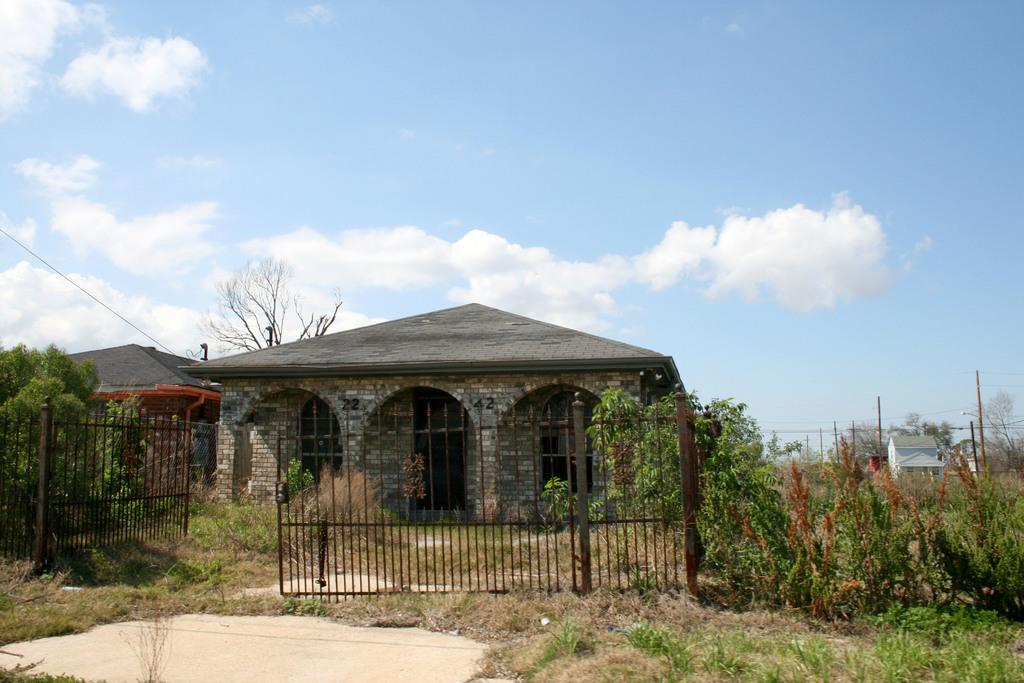What type of vegetation can be seen in the image? There is grass and plants in the image. What type of structure is present in the image? There is a gate in the image. What other objects can be seen in the image? There are poles and houses in the image. What type of natural elements are visible in the image? There are trees and the sky in the image. What can be seen in the sky in the image? There are clouds in the sky. What type of marble is used to decorate the rail in the image? There is no rail or marble present in the image. How many bears can be seen playing in the grass in the image? There are no bears present in the image. 